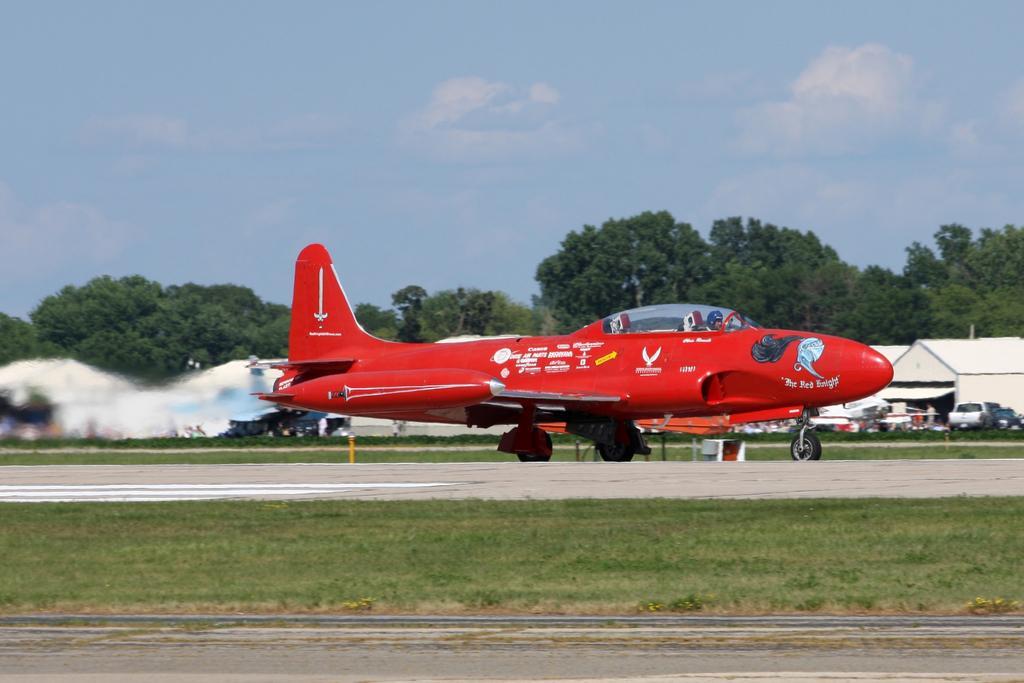Can you describe this image briefly? This image consists of a plane in red color. It is on the road. At the bottom, there is green grass on the ground. In the background, there are trees. At the top, there are clouds in the sky. And we can see the vehicles and a small house in the background. 